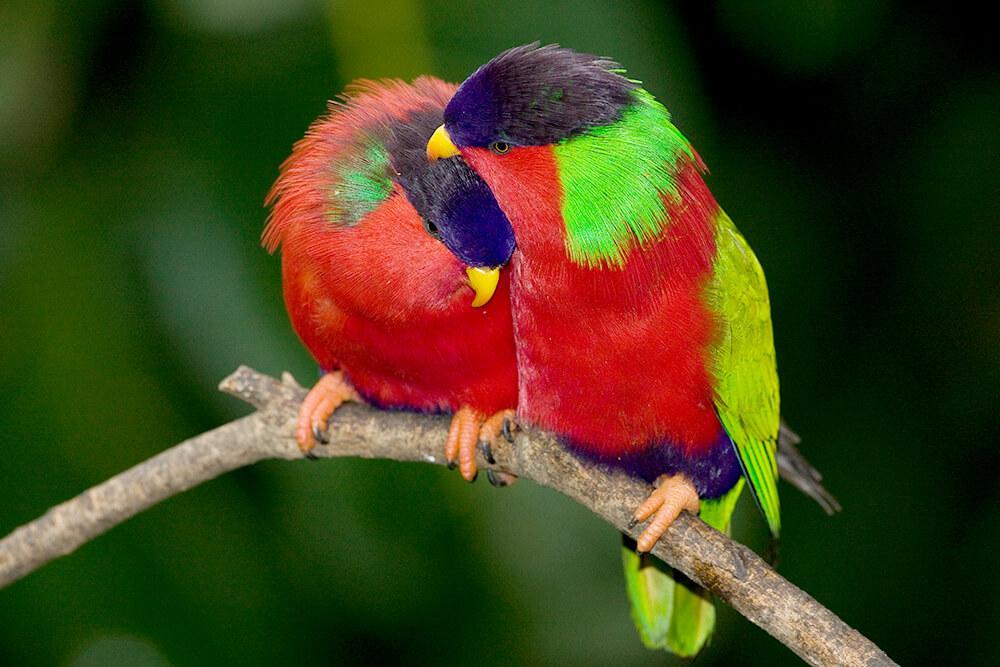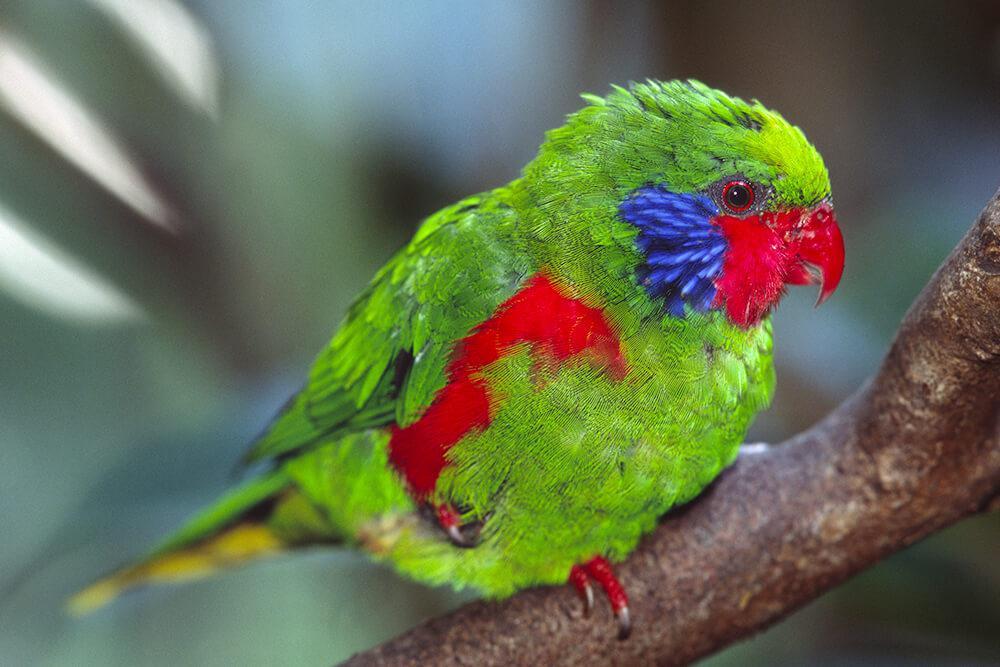The first image is the image on the left, the second image is the image on the right. Evaluate the accuracy of this statement regarding the images: "A single bird is perched on the edge of a bowl and facing left in one image.". Is it true? Answer yes or no. No. The first image is the image on the left, the second image is the image on the right. For the images shown, is this caption "There are 3 birds in the image pair" true? Answer yes or no. Yes. 